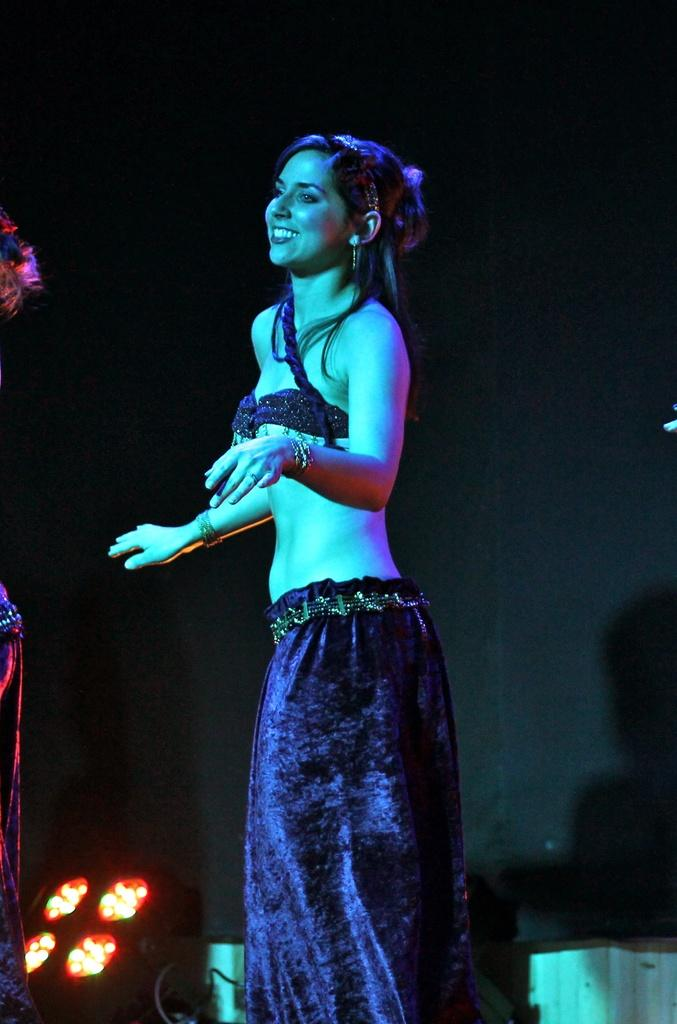Who is the main subject in the image? There is a lady in the image. What is the lady doing in the image? The lady is dancing. What can be seen in the background of the image? There are lights in the background of the image. How would you describe the overall lighting in the image? The background of the image is dark. What type of space-related equipment can be seen in the image? There is no space-related equipment present in the image. How many bulbs are visible in the image? There is no mention of bulbs in the provided facts, so we cannot determine the number of bulbs in the image. 